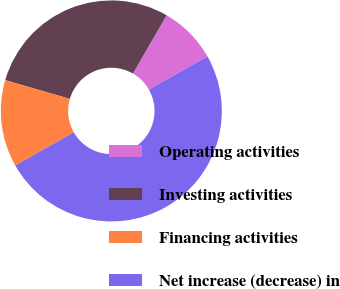Convert chart to OTSL. <chart><loc_0><loc_0><loc_500><loc_500><pie_chart><fcel>Operating activities<fcel>Investing activities<fcel>Financing activities<fcel>Net increase (decrease) in<nl><fcel>8.44%<fcel>28.85%<fcel>12.71%<fcel>50.0%<nl></chart> 